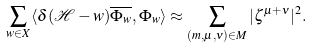Convert formula to latex. <formula><loc_0><loc_0><loc_500><loc_500>\sum _ { w \in X } \langle \delta ( \mathcal { H } - w ) \overline { \Phi _ { w } } , \Phi _ { w } \rangle \approx \sum _ { ( m , \mu , \nu ) \in M } | \zeta ^ { \mu + \nu } | ^ { 2 } .</formula> 